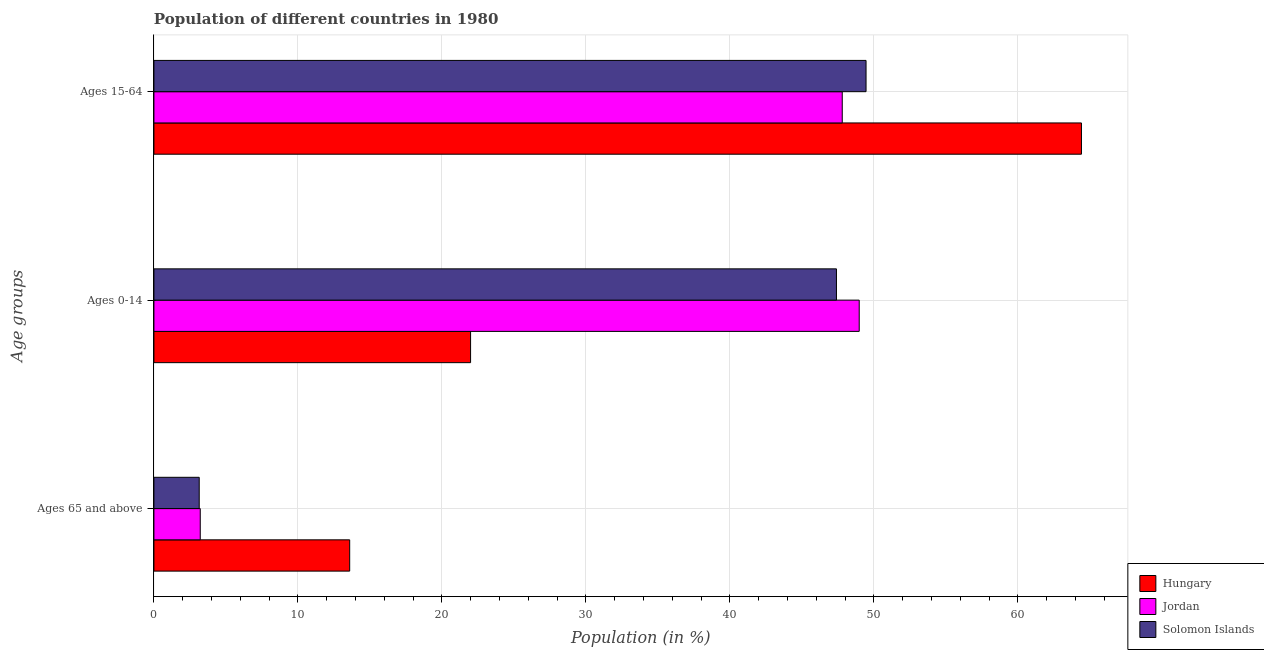How many groups of bars are there?
Keep it short and to the point. 3. Are the number of bars per tick equal to the number of legend labels?
Offer a very short reply. Yes. How many bars are there on the 2nd tick from the top?
Keep it short and to the point. 3. How many bars are there on the 3rd tick from the bottom?
Provide a succinct answer. 3. What is the label of the 3rd group of bars from the top?
Keep it short and to the point. Ages 65 and above. What is the percentage of population within the age-group of 65 and above in Solomon Islands?
Offer a very short reply. 3.15. Across all countries, what is the maximum percentage of population within the age-group of 65 and above?
Make the answer very short. 13.6. Across all countries, what is the minimum percentage of population within the age-group 15-64?
Your answer should be compact. 47.8. In which country was the percentage of population within the age-group of 65 and above maximum?
Your answer should be compact. Hungary. In which country was the percentage of population within the age-group 0-14 minimum?
Your answer should be very brief. Hungary. What is the total percentage of population within the age-group of 65 and above in the graph?
Give a very brief answer. 19.96. What is the difference between the percentage of population within the age-group 15-64 in Hungary and that in Solomon Islands?
Give a very brief answer. 14.96. What is the difference between the percentage of population within the age-group 0-14 in Solomon Islands and the percentage of population within the age-group of 65 and above in Hungary?
Offer a terse response. 33.8. What is the average percentage of population within the age-group of 65 and above per country?
Give a very brief answer. 6.65. What is the difference between the percentage of population within the age-group 0-14 and percentage of population within the age-group of 65 and above in Jordan?
Your response must be concise. 45.76. In how many countries, is the percentage of population within the age-group 15-64 greater than 28 %?
Your answer should be compact. 3. What is the ratio of the percentage of population within the age-group of 65 and above in Solomon Islands to that in Hungary?
Ensure brevity in your answer.  0.23. Is the percentage of population within the age-group of 65 and above in Jordan less than that in Solomon Islands?
Your response must be concise. No. What is the difference between the highest and the second highest percentage of population within the age-group of 65 and above?
Make the answer very short. 10.38. What is the difference between the highest and the lowest percentage of population within the age-group 0-14?
Give a very brief answer. 26.99. What does the 2nd bar from the top in Ages 0-14 represents?
Offer a terse response. Jordan. What does the 1st bar from the bottom in Ages 65 and above represents?
Your response must be concise. Hungary. What is the difference between two consecutive major ticks on the X-axis?
Your response must be concise. 10. Does the graph contain any zero values?
Ensure brevity in your answer.  No. Does the graph contain grids?
Offer a very short reply. Yes. Where does the legend appear in the graph?
Make the answer very short. Bottom right. How many legend labels are there?
Your response must be concise. 3. How are the legend labels stacked?
Offer a terse response. Vertical. What is the title of the graph?
Your response must be concise. Population of different countries in 1980. What is the label or title of the X-axis?
Keep it short and to the point. Population (in %). What is the label or title of the Y-axis?
Your answer should be very brief. Age groups. What is the Population (in %) of Hungary in Ages 65 and above?
Offer a terse response. 13.6. What is the Population (in %) in Jordan in Ages 65 and above?
Make the answer very short. 3.22. What is the Population (in %) in Solomon Islands in Ages 65 and above?
Make the answer very short. 3.15. What is the Population (in %) of Hungary in Ages 0-14?
Provide a succinct answer. 21.99. What is the Population (in %) in Jordan in Ages 0-14?
Keep it short and to the point. 48.98. What is the Population (in %) in Solomon Islands in Ages 0-14?
Keep it short and to the point. 47.4. What is the Population (in %) of Hungary in Ages 15-64?
Your answer should be very brief. 64.41. What is the Population (in %) in Jordan in Ages 15-64?
Make the answer very short. 47.8. What is the Population (in %) in Solomon Islands in Ages 15-64?
Keep it short and to the point. 49.45. Across all Age groups, what is the maximum Population (in %) in Hungary?
Offer a terse response. 64.41. Across all Age groups, what is the maximum Population (in %) in Jordan?
Ensure brevity in your answer.  48.98. Across all Age groups, what is the maximum Population (in %) in Solomon Islands?
Provide a succinct answer. 49.45. Across all Age groups, what is the minimum Population (in %) of Hungary?
Make the answer very short. 13.6. Across all Age groups, what is the minimum Population (in %) in Jordan?
Your answer should be compact. 3.22. Across all Age groups, what is the minimum Population (in %) of Solomon Islands?
Offer a terse response. 3.15. What is the total Population (in %) of Jordan in the graph?
Make the answer very short. 100. What is the total Population (in %) in Solomon Islands in the graph?
Provide a succinct answer. 100. What is the difference between the Population (in %) of Hungary in Ages 65 and above and that in Ages 0-14?
Your response must be concise. -8.4. What is the difference between the Population (in %) in Jordan in Ages 65 and above and that in Ages 0-14?
Your answer should be very brief. -45.76. What is the difference between the Population (in %) of Solomon Islands in Ages 65 and above and that in Ages 0-14?
Keep it short and to the point. -44.25. What is the difference between the Population (in %) in Hungary in Ages 65 and above and that in Ages 15-64?
Your answer should be compact. -50.82. What is the difference between the Population (in %) of Jordan in Ages 65 and above and that in Ages 15-64?
Your answer should be compact. -44.59. What is the difference between the Population (in %) of Solomon Islands in Ages 65 and above and that in Ages 15-64?
Your answer should be compact. -46.31. What is the difference between the Population (in %) in Hungary in Ages 0-14 and that in Ages 15-64?
Provide a succinct answer. -42.42. What is the difference between the Population (in %) of Jordan in Ages 0-14 and that in Ages 15-64?
Provide a short and direct response. 1.18. What is the difference between the Population (in %) of Solomon Islands in Ages 0-14 and that in Ages 15-64?
Give a very brief answer. -2.06. What is the difference between the Population (in %) in Hungary in Ages 65 and above and the Population (in %) in Jordan in Ages 0-14?
Offer a very short reply. -35.38. What is the difference between the Population (in %) of Hungary in Ages 65 and above and the Population (in %) of Solomon Islands in Ages 0-14?
Provide a succinct answer. -33.8. What is the difference between the Population (in %) in Jordan in Ages 65 and above and the Population (in %) in Solomon Islands in Ages 0-14?
Provide a short and direct response. -44.18. What is the difference between the Population (in %) of Hungary in Ages 65 and above and the Population (in %) of Jordan in Ages 15-64?
Your answer should be compact. -34.21. What is the difference between the Population (in %) of Hungary in Ages 65 and above and the Population (in %) of Solomon Islands in Ages 15-64?
Ensure brevity in your answer.  -35.86. What is the difference between the Population (in %) in Jordan in Ages 65 and above and the Population (in %) in Solomon Islands in Ages 15-64?
Ensure brevity in your answer.  -46.24. What is the difference between the Population (in %) of Hungary in Ages 0-14 and the Population (in %) of Jordan in Ages 15-64?
Provide a succinct answer. -25.81. What is the difference between the Population (in %) of Hungary in Ages 0-14 and the Population (in %) of Solomon Islands in Ages 15-64?
Ensure brevity in your answer.  -27.46. What is the difference between the Population (in %) of Jordan in Ages 0-14 and the Population (in %) of Solomon Islands in Ages 15-64?
Provide a short and direct response. -0.47. What is the average Population (in %) of Hungary per Age groups?
Your response must be concise. 33.33. What is the average Population (in %) in Jordan per Age groups?
Give a very brief answer. 33.33. What is the average Population (in %) of Solomon Islands per Age groups?
Your answer should be compact. 33.33. What is the difference between the Population (in %) in Hungary and Population (in %) in Jordan in Ages 65 and above?
Offer a very short reply. 10.38. What is the difference between the Population (in %) of Hungary and Population (in %) of Solomon Islands in Ages 65 and above?
Ensure brevity in your answer.  10.45. What is the difference between the Population (in %) of Jordan and Population (in %) of Solomon Islands in Ages 65 and above?
Offer a very short reply. 0.07. What is the difference between the Population (in %) of Hungary and Population (in %) of Jordan in Ages 0-14?
Your response must be concise. -26.99. What is the difference between the Population (in %) of Hungary and Population (in %) of Solomon Islands in Ages 0-14?
Offer a very short reply. -25.41. What is the difference between the Population (in %) in Jordan and Population (in %) in Solomon Islands in Ages 0-14?
Ensure brevity in your answer.  1.58. What is the difference between the Population (in %) of Hungary and Population (in %) of Jordan in Ages 15-64?
Give a very brief answer. 16.61. What is the difference between the Population (in %) in Hungary and Population (in %) in Solomon Islands in Ages 15-64?
Provide a succinct answer. 14.96. What is the difference between the Population (in %) of Jordan and Population (in %) of Solomon Islands in Ages 15-64?
Your answer should be compact. -1.65. What is the ratio of the Population (in %) of Hungary in Ages 65 and above to that in Ages 0-14?
Offer a very short reply. 0.62. What is the ratio of the Population (in %) of Jordan in Ages 65 and above to that in Ages 0-14?
Offer a terse response. 0.07. What is the ratio of the Population (in %) of Solomon Islands in Ages 65 and above to that in Ages 0-14?
Your answer should be compact. 0.07. What is the ratio of the Population (in %) in Hungary in Ages 65 and above to that in Ages 15-64?
Offer a very short reply. 0.21. What is the ratio of the Population (in %) of Jordan in Ages 65 and above to that in Ages 15-64?
Make the answer very short. 0.07. What is the ratio of the Population (in %) in Solomon Islands in Ages 65 and above to that in Ages 15-64?
Keep it short and to the point. 0.06. What is the ratio of the Population (in %) of Hungary in Ages 0-14 to that in Ages 15-64?
Give a very brief answer. 0.34. What is the ratio of the Population (in %) of Jordan in Ages 0-14 to that in Ages 15-64?
Keep it short and to the point. 1.02. What is the ratio of the Population (in %) in Solomon Islands in Ages 0-14 to that in Ages 15-64?
Your answer should be compact. 0.96. What is the difference between the highest and the second highest Population (in %) in Hungary?
Ensure brevity in your answer.  42.42. What is the difference between the highest and the second highest Population (in %) in Jordan?
Your answer should be compact. 1.18. What is the difference between the highest and the second highest Population (in %) of Solomon Islands?
Ensure brevity in your answer.  2.06. What is the difference between the highest and the lowest Population (in %) in Hungary?
Provide a short and direct response. 50.82. What is the difference between the highest and the lowest Population (in %) in Jordan?
Your response must be concise. 45.76. What is the difference between the highest and the lowest Population (in %) in Solomon Islands?
Your response must be concise. 46.31. 